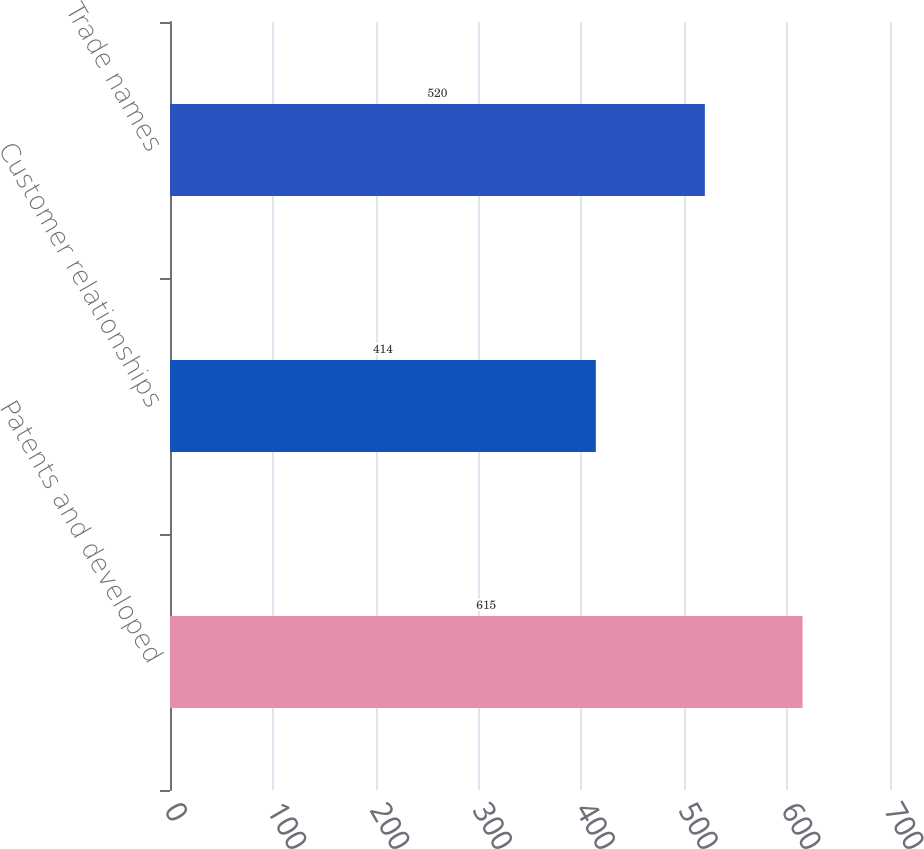Convert chart. <chart><loc_0><loc_0><loc_500><loc_500><bar_chart><fcel>Patents and developed<fcel>Customer relationships<fcel>Trade names<nl><fcel>615<fcel>414<fcel>520<nl></chart> 